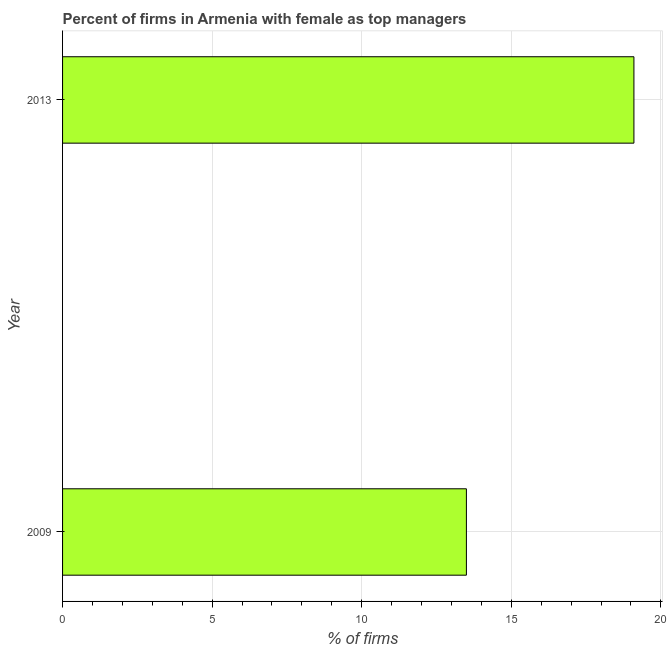Does the graph contain grids?
Your answer should be very brief. Yes. What is the title of the graph?
Your answer should be very brief. Percent of firms in Armenia with female as top managers. What is the label or title of the X-axis?
Keep it short and to the point. % of firms. What is the label or title of the Y-axis?
Make the answer very short. Year. Across all years, what is the minimum percentage of firms with female as top manager?
Ensure brevity in your answer.  13.5. In which year was the percentage of firms with female as top manager maximum?
Keep it short and to the point. 2013. In which year was the percentage of firms with female as top manager minimum?
Your answer should be very brief. 2009. What is the sum of the percentage of firms with female as top manager?
Provide a short and direct response. 32.6. What is the average percentage of firms with female as top manager per year?
Your answer should be compact. 16.3. What is the median percentage of firms with female as top manager?
Ensure brevity in your answer.  16.3. Do a majority of the years between 2009 and 2013 (inclusive) have percentage of firms with female as top manager greater than 17 %?
Keep it short and to the point. No. What is the ratio of the percentage of firms with female as top manager in 2009 to that in 2013?
Offer a very short reply. 0.71. How many years are there in the graph?
Keep it short and to the point. 2. Are the values on the major ticks of X-axis written in scientific E-notation?
Ensure brevity in your answer.  No. What is the % of firms of 2009?
Keep it short and to the point. 13.5. What is the % of firms of 2013?
Your answer should be very brief. 19.1. What is the difference between the % of firms in 2009 and 2013?
Offer a terse response. -5.6. What is the ratio of the % of firms in 2009 to that in 2013?
Provide a short and direct response. 0.71. 